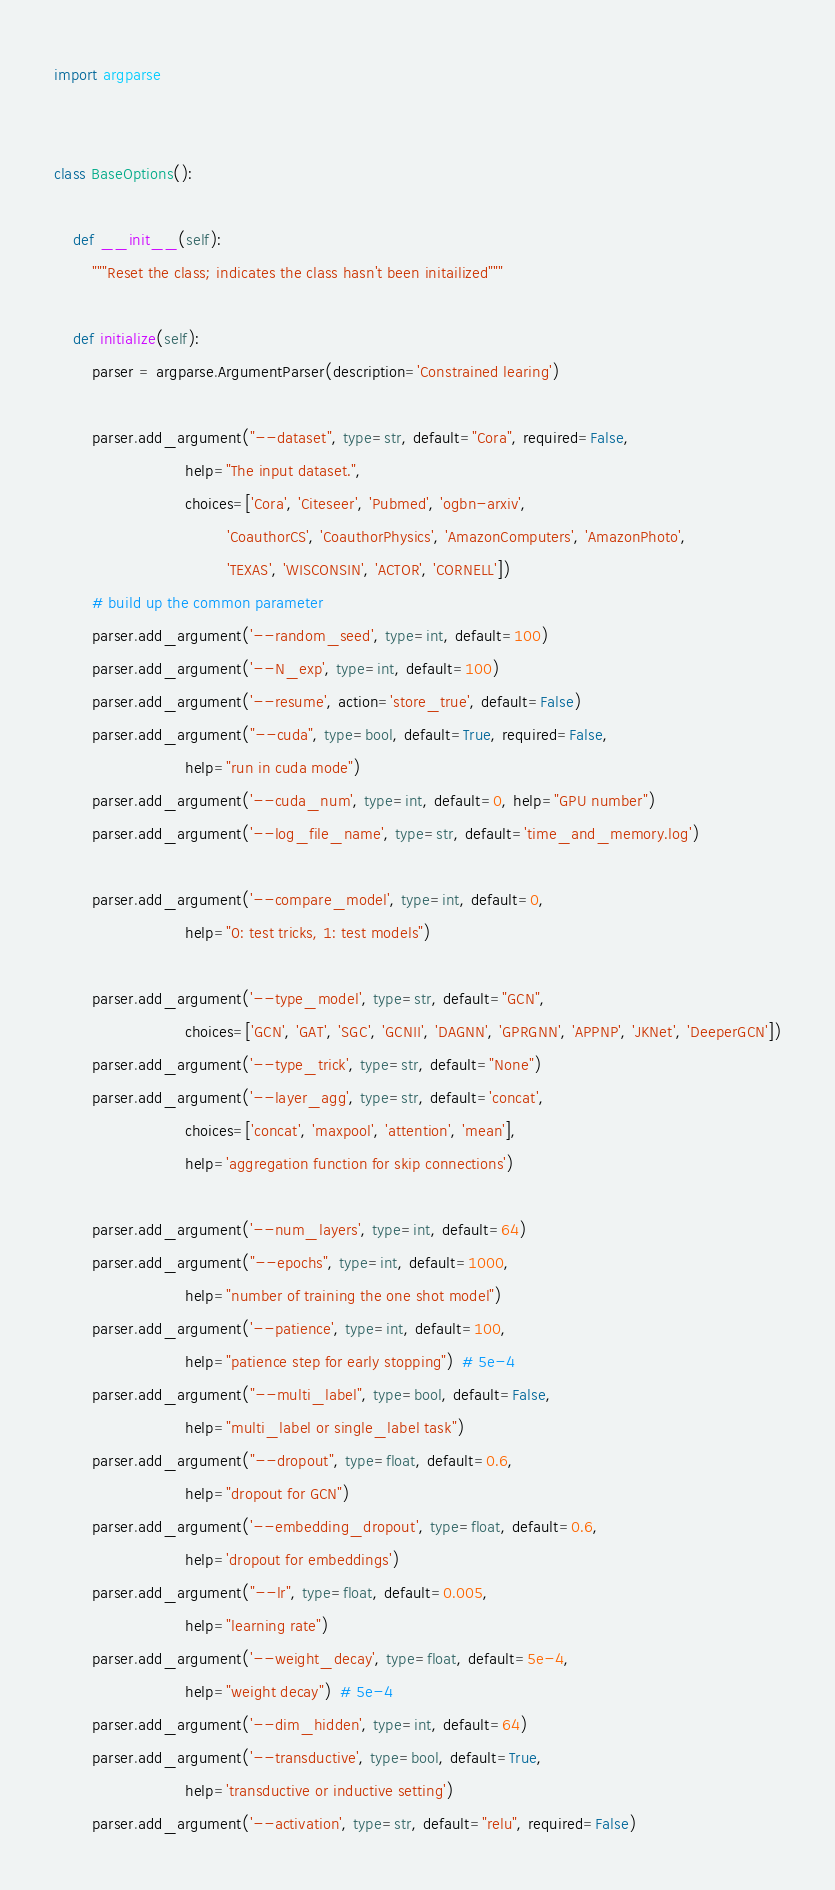<code> <loc_0><loc_0><loc_500><loc_500><_Python_>import argparse


class BaseOptions():

    def __init__(self):
        """Reset the class; indicates the class hasn't been initailized"""

    def initialize(self):
        parser = argparse.ArgumentParser(description='Constrained learing')

        parser.add_argument("--dataset", type=str, default="Cora", required=False,
                            help="The input dataset.",
                            choices=['Cora', 'Citeseer', 'Pubmed', 'ogbn-arxiv',
                                     'CoauthorCS', 'CoauthorPhysics', 'AmazonComputers', 'AmazonPhoto',
                                     'TEXAS', 'WISCONSIN', 'ACTOR', 'CORNELL'])
        # build up the common parameter
        parser.add_argument('--random_seed', type=int, default=100)
        parser.add_argument('--N_exp', type=int, default=100)
        parser.add_argument('--resume', action='store_true', default=False)
        parser.add_argument("--cuda", type=bool, default=True, required=False,
                            help="run in cuda mode")
        parser.add_argument('--cuda_num', type=int, default=0, help="GPU number")
        parser.add_argument('--log_file_name', type=str, default='time_and_memory.log')

        parser.add_argument('--compare_model', type=int, default=0,
                            help="0: test tricks, 1: test models")

        parser.add_argument('--type_model', type=str, default="GCN",
                            choices=['GCN', 'GAT', 'SGC', 'GCNII', 'DAGNN', 'GPRGNN', 'APPNP', 'JKNet', 'DeeperGCN'])
        parser.add_argument('--type_trick', type=str, default="None")
        parser.add_argument('--layer_agg', type=str, default='concat',
                            choices=['concat', 'maxpool', 'attention', 'mean'],
                            help='aggregation function for skip connections')

        parser.add_argument('--num_layers', type=int, default=64)
        parser.add_argument("--epochs", type=int, default=1000,
                            help="number of training the one shot model")
        parser.add_argument('--patience', type=int, default=100,
                            help="patience step for early stopping")  # 5e-4
        parser.add_argument("--multi_label", type=bool, default=False,
                            help="multi_label or single_label task")
        parser.add_argument("--dropout", type=float, default=0.6,
                            help="dropout for GCN")
        parser.add_argument('--embedding_dropout', type=float, default=0.6,
                            help='dropout for embeddings')
        parser.add_argument("--lr", type=float, default=0.005,
                            help="learning rate")
        parser.add_argument('--weight_decay', type=float, default=5e-4,
                            help="weight decay")  # 5e-4
        parser.add_argument('--dim_hidden', type=int, default=64)
        parser.add_argument('--transductive', type=bool, default=True,
                            help='transductive or inductive setting')
        parser.add_argument('--activation', type=str, default="relu", required=False)
</code> 